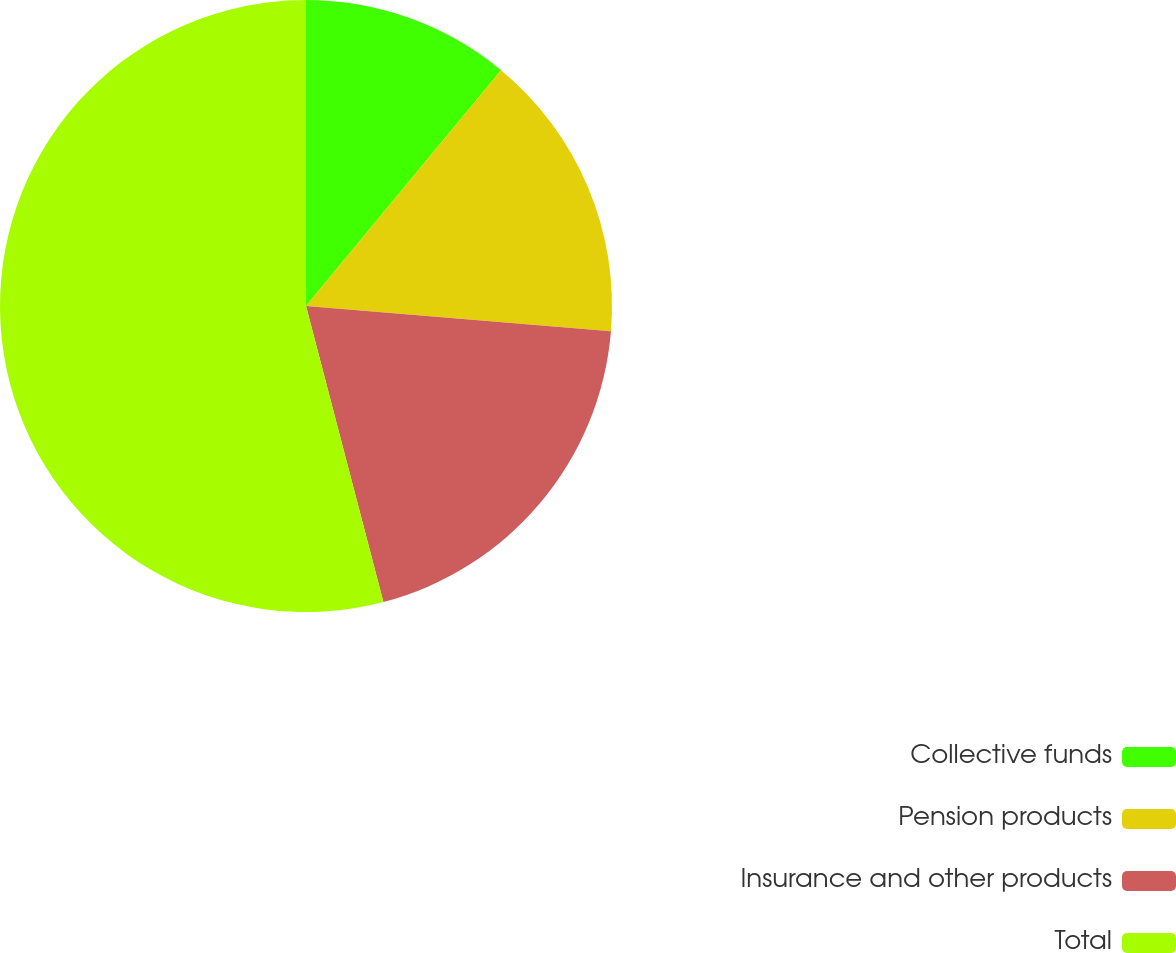Convert chart to OTSL. <chart><loc_0><loc_0><loc_500><loc_500><pie_chart><fcel>Collective funds<fcel>Pension products<fcel>Insurance and other products<fcel>Total<nl><fcel>11.0%<fcel>15.31%<fcel>19.62%<fcel>54.07%<nl></chart> 